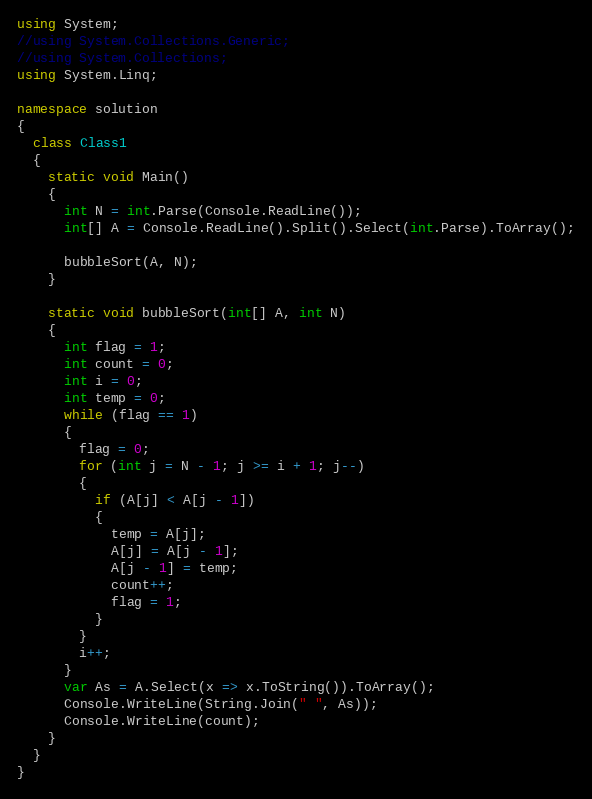<code> <loc_0><loc_0><loc_500><loc_500><_C#_>using System;
//using System.Collections.Generic;
//using System.Collections;
using System.Linq;

namespace solution
{
  class Class1
  {
    static void Main()
    {
      int N = int.Parse(Console.ReadLine());
      int[] A = Console.ReadLine().Split().Select(int.Parse).ToArray();

      bubbleSort(A, N);
    }

    static void bubbleSort(int[] A, int N)
    {
      int flag = 1;
      int count = 0;
      int i = 0;
      int temp = 0;
      while (flag == 1)
      {
        flag = 0;
        for (int j = N - 1; j >= i + 1; j--)
        {
          if (A[j] < A[j - 1])
          {
            temp = A[j];
            A[j] = A[j - 1];
            A[j - 1] = temp;
            count++;
            flag = 1;
          }
        }
        i++;
      }
      var As = A.Select(x => x.ToString()).ToArray();
      Console.WriteLine(String.Join(" ", As));
      Console.WriteLine(count);
    }
  }
}






</code> 